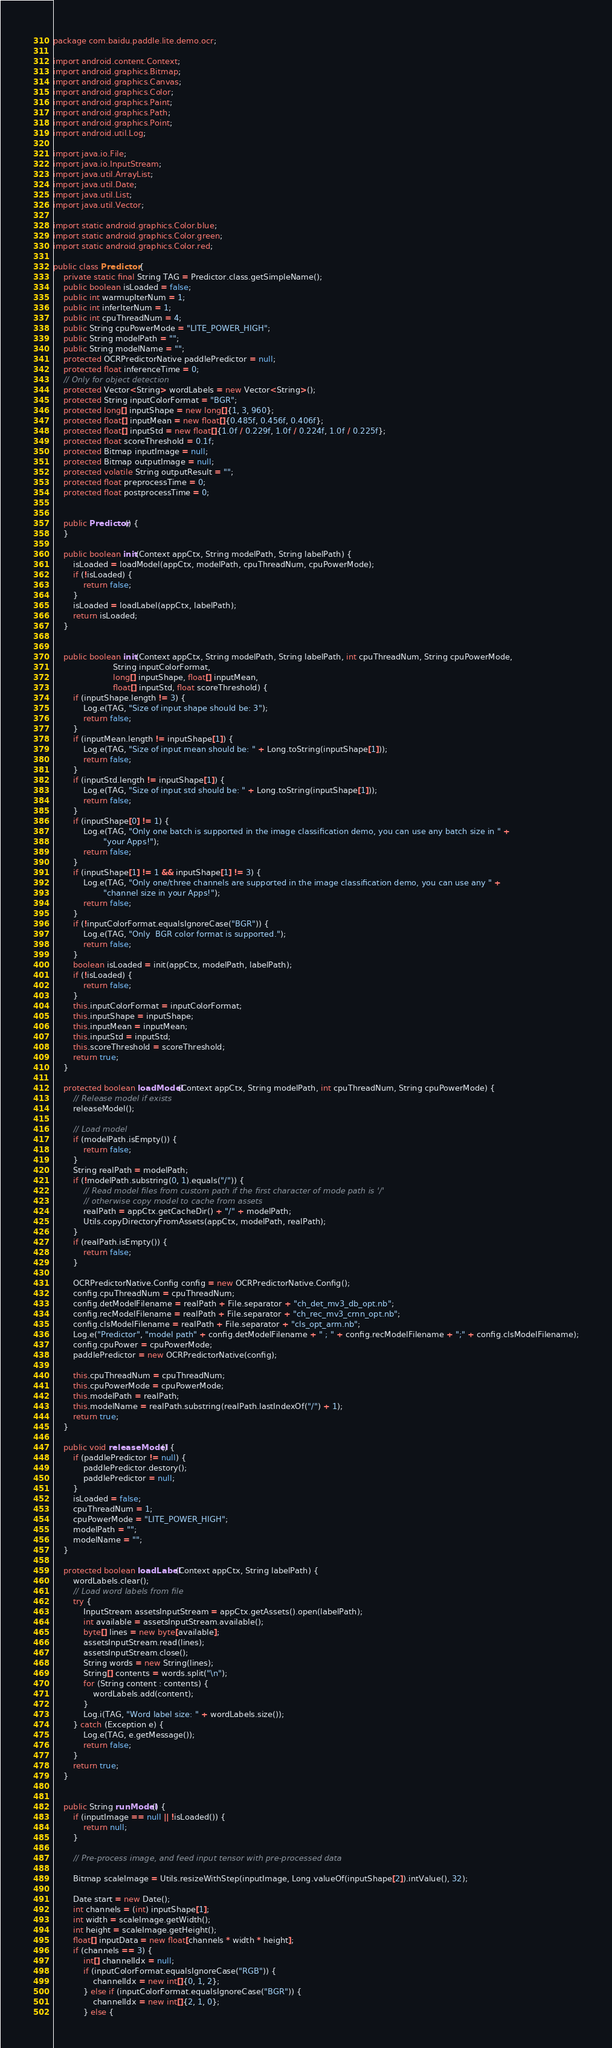Convert code to text. <code><loc_0><loc_0><loc_500><loc_500><_Java_>package com.baidu.paddle.lite.demo.ocr;

import android.content.Context;
import android.graphics.Bitmap;
import android.graphics.Canvas;
import android.graphics.Color;
import android.graphics.Paint;
import android.graphics.Path;
import android.graphics.Point;
import android.util.Log;

import java.io.File;
import java.io.InputStream;
import java.util.ArrayList;
import java.util.Date;
import java.util.List;
import java.util.Vector;

import static android.graphics.Color.blue;
import static android.graphics.Color.green;
import static android.graphics.Color.red;

public class Predictor {
    private static final String TAG = Predictor.class.getSimpleName();
    public boolean isLoaded = false;
    public int warmupIterNum = 1;
    public int inferIterNum = 1;
    public int cpuThreadNum = 4;
    public String cpuPowerMode = "LITE_POWER_HIGH";
    public String modelPath = "";
    public String modelName = "";
    protected OCRPredictorNative paddlePredictor = null;
    protected float inferenceTime = 0;
    // Only for object detection
    protected Vector<String> wordLabels = new Vector<String>();
    protected String inputColorFormat = "BGR";
    protected long[] inputShape = new long[]{1, 3, 960};
    protected float[] inputMean = new float[]{0.485f, 0.456f, 0.406f};
    protected float[] inputStd = new float[]{1.0f / 0.229f, 1.0f / 0.224f, 1.0f / 0.225f};
    protected float scoreThreshold = 0.1f;
    protected Bitmap inputImage = null;
    protected Bitmap outputImage = null;
    protected volatile String outputResult = "";
    protected float preprocessTime = 0;
    protected float postprocessTime = 0;


    public Predictor() {
    }

    public boolean init(Context appCtx, String modelPath, String labelPath) {
        isLoaded = loadModel(appCtx, modelPath, cpuThreadNum, cpuPowerMode);
        if (!isLoaded) {
            return false;
        }
        isLoaded = loadLabel(appCtx, labelPath);
        return isLoaded;
    }


    public boolean init(Context appCtx, String modelPath, String labelPath, int cpuThreadNum, String cpuPowerMode,
                        String inputColorFormat,
                        long[] inputShape, float[] inputMean,
                        float[] inputStd, float scoreThreshold) {
        if (inputShape.length != 3) {
            Log.e(TAG, "Size of input shape should be: 3");
            return false;
        }
        if (inputMean.length != inputShape[1]) {
            Log.e(TAG, "Size of input mean should be: " + Long.toString(inputShape[1]));
            return false;
        }
        if (inputStd.length != inputShape[1]) {
            Log.e(TAG, "Size of input std should be: " + Long.toString(inputShape[1]));
            return false;
        }
        if (inputShape[0] != 1) {
            Log.e(TAG, "Only one batch is supported in the image classification demo, you can use any batch size in " +
                    "your Apps!");
            return false;
        }
        if (inputShape[1] != 1 && inputShape[1] != 3) {
            Log.e(TAG, "Only one/three channels are supported in the image classification demo, you can use any " +
                    "channel size in your Apps!");
            return false;
        }
        if (!inputColorFormat.equalsIgnoreCase("BGR")) {
            Log.e(TAG, "Only  BGR color format is supported.");
            return false;
        }
        boolean isLoaded = init(appCtx, modelPath, labelPath);
        if (!isLoaded) {
            return false;
        }
        this.inputColorFormat = inputColorFormat;
        this.inputShape = inputShape;
        this.inputMean = inputMean;
        this.inputStd = inputStd;
        this.scoreThreshold = scoreThreshold;
        return true;
    }

    protected boolean loadModel(Context appCtx, String modelPath, int cpuThreadNum, String cpuPowerMode) {
        // Release model if exists
        releaseModel();

        // Load model
        if (modelPath.isEmpty()) {
            return false;
        }
        String realPath = modelPath;
        if (!modelPath.substring(0, 1).equals("/")) {
            // Read model files from custom path if the first character of mode path is '/'
            // otherwise copy model to cache from assets
            realPath = appCtx.getCacheDir() + "/" + modelPath;
            Utils.copyDirectoryFromAssets(appCtx, modelPath, realPath);
        }
        if (realPath.isEmpty()) {
            return false;
        }

        OCRPredictorNative.Config config = new OCRPredictorNative.Config();
        config.cpuThreadNum = cpuThreadNum;
        config.detModelFilename = realPath + File.separator + "ch_det_mv3_db_opt.nb";
        config.recModelFilename = realPath + File.separator + "ch_rec_mv3_crnn_opt.nb";
        config.clsModelFilename = realPath + File.separator + "cls_opt_arm.nb";
        Log.e("Predictor", "model path" + config.detModelFilename + " ; " + config.recModelFilename + ";" + config.clsModelFilename);
        config.cpuPower = cpuPowerMode;
        paddlePredictor = new OCRPredictorNative(config);

        this.cpuThreadNum = cpuThreadNum;
        this.cpuPowerMode = cpuPowerMode;
        this.modelPath = realPath;
        this.modelName = realPath.substring(realPath.lastIndexOf("/") + 1);
        return true;
    }

    public void releaseModel() {
        if (paddlePredictor != null) {
            paddlePredictor.destory();
            paddlePredictor = null;
        }
        isLoaded = false;
        cpuThreadNum = 1;
        cpuPowerMode = "LITE_POWER_HIGH";
        modelPath = "";
        modelName = "";
    }

    protected boolean loadLabel(Context appCtx, String labelPath) {
        wordLabels.clear();
        // Load word labels from file
        try {
            InputStream assetsInputStream = appCtx.getAssets().open(labelPath);
            int available = assetsInputStream.available();
            byte[] lines = new byte[available];
            assetsInputStream.read(lines);
            assetsInputStream.close();
            String words = new String(lines);
            String[] contents = words.split("\n");
            for (String content : contents) {
                wordLabels.add(content);
            }
            Log.i(TAG, "Word label size: " + wordLabels.size());
        } catch (Exception e) {
            Log.e(TAG, e.getMessage());
            return false;
        }
        return true;
    }


    public String runModel() {
        if (inputImage == null || !isLoaded()) {
            return null;
        }

        // Pre-process image, and feed input tensor with pre-processed data

        Bitmap scaleImage = Utils.resizeWithStep(inputImage, Long.valueOf(inputShape[2]).intValue(), 32);

        Date start = new Date();
        int channels = (int) inputShape[1];
        int width = scaleImage.getWidth();
        int height = scaleImage.getHeight();
        float[] inputData = new float[channels * width * height];
        if (channels == 3) {
            int[] channelIdx = null;
            if (inputColorFormat.equalsIgnoreCase("RGB")) {
                channelIdx = new int[]{0, 1, 2};
            } else if (inputColorFormat.equalsIgnoreCase("BGR")) {
                channelIdx = new int[]{2, 1, 0};
            } else {</code> 